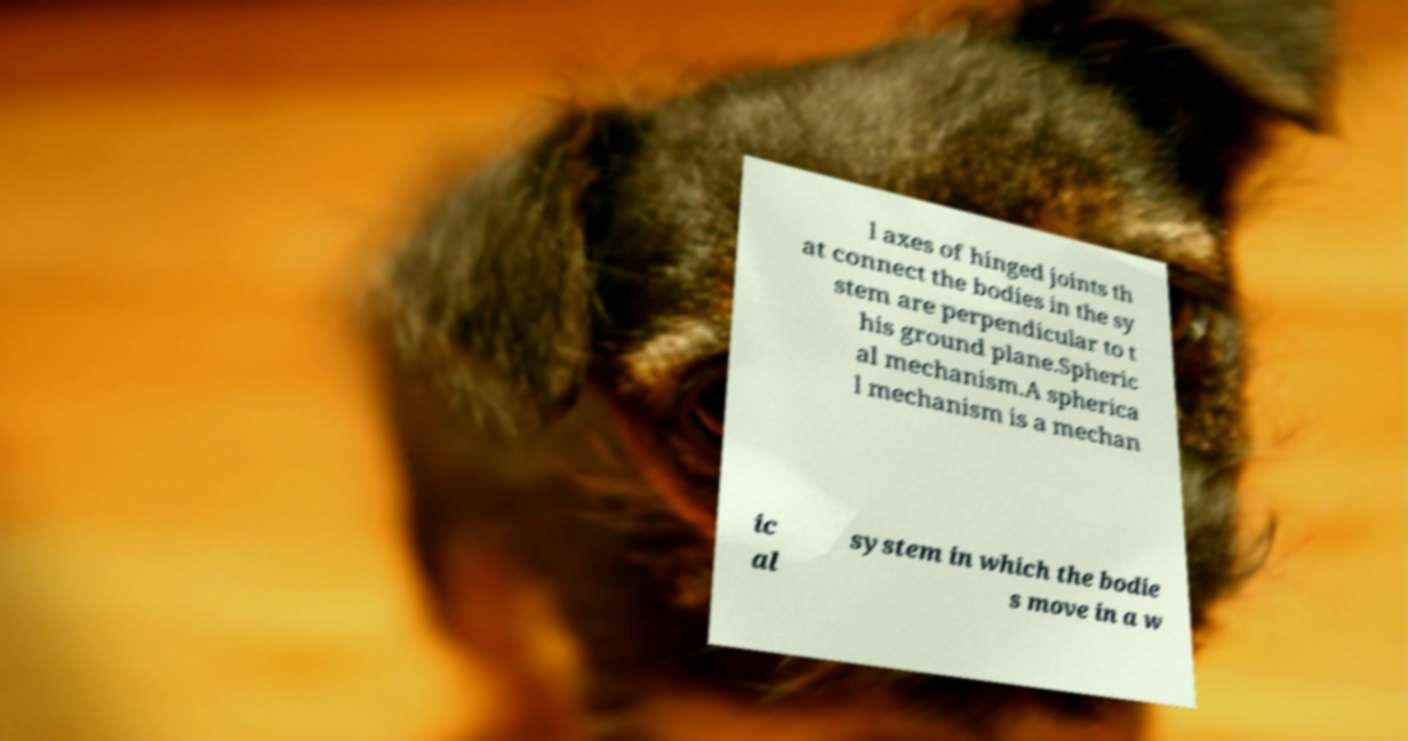Could you assist in decoding the text presented in this image and type it out clearly? l axes of hinged joints th at connect the bodies in the sy stem are perpendicular to t his ground plane.Spheric al mechanism.A spherica l mechanism is a mechan ic al system in which the bodie s move in a w 